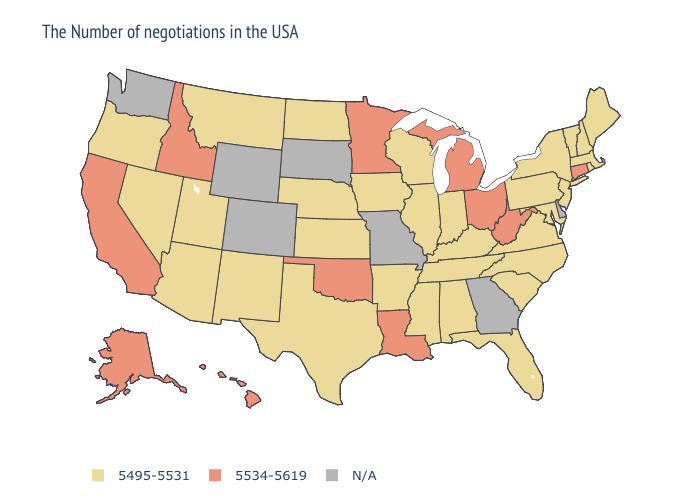Name the states that have a value in the range 5534-5619?
Short answer required. Connecticut, West Virginia, Ohio, Michigan, Louisiana, Minnesota, Oklahoma, Idaho, California, Alaska, Hawaii. Among the states that border Colorado , which have the highest value?
Give a very brief answer. Oklahoma. What is the value of Kansas?
Short answer required. 5495-5531. What is the value of South Carolina?
Short answer required. 5495-5531. What is the lowest value in the South?
Short answer required. 5495-5531. What is the highest value in states that border North Dakota?
Keep it brief. 5534-5619. Name the states that have a value in the range N/A?
Write a very short answer. Delaware, Georgia, Missouri, South Dakota, Wyoming, Colorado, Washington. Among the states that border Ohio , does Kentucky have the highest value?
Short answer required. No. What is the value of Michigan?
Short answer required. 5534-5619. What is the value of Texas?
Keep it brief. 5495-5531. 